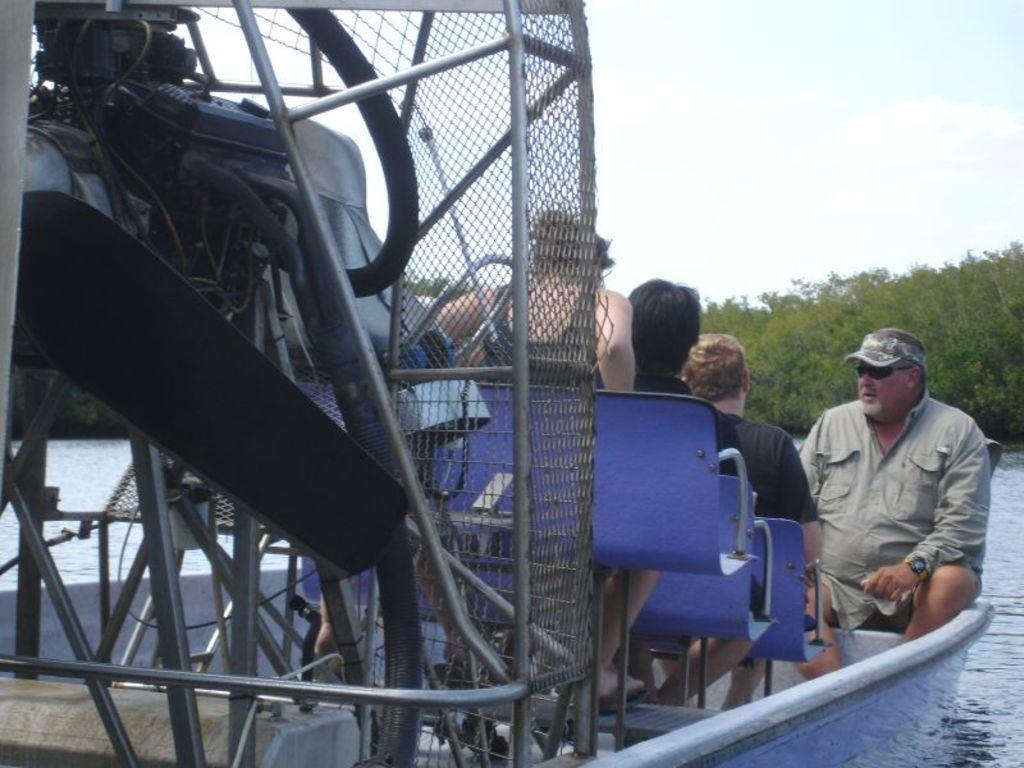What are the people in the image doing? There are persons sitting in a boat in the image. What object can be seen in the image that is made of iron? There is an iron grill in the image. What type of vehicle is present in the image? There is a motor vehicle in the image. What can be seen in the background of the image? The sky with clouds, trees, and water are visible in the background. How many ladybugs are sitting on the motor vehicle in the image? There are no ladybugs present in the image, so it is not possible to determine how many would be sitting on the motor vehicle. 